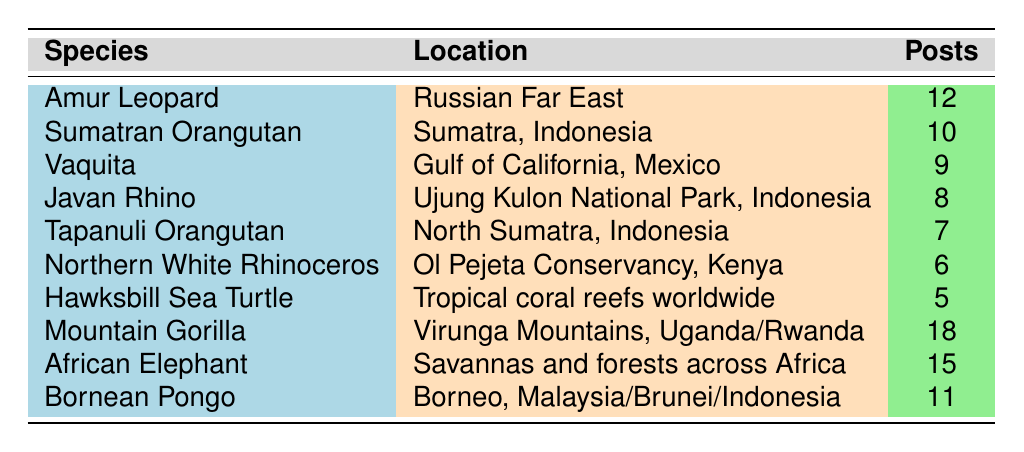What species has the highest number of highlighted posts? The species with the highest number of highlighted posts is the Mountain Gorilla, which has 18 posts.
Answer: Mountain Gorilla How many posts were highlighted for the African Elephant? The African Elephant has 15 highlighted posts as indicated in the table.
Answer: 15 What is the total number of highlighted posts across all species? By summing the highlighted posts: 12 + 10 + 9 + 8 + 7 + 6 + 5 + 18 + 15 + 11 = 91, the total number of highlighted posts across all species is 91.
Answer: 91 Is the Javan Rhino considered critically endangered? According to the table, the Javan Rhino is listed as "Critically Endangered," making this statement true.
Answer: Yes What is the average number of highlighted posts for species at the critically endangered status? The critically endangered species (8 in total) have posts highlighted: 12 + 10 + 9 + 8 + 7 + 6 + 5 + 11 = 68. The average is 68/8 = 8.5.
Answer: 8.5 Which location has the most highlighted posts combined from both the Mountain Gorilla and the African Elephant? The Mountain Gorilla is found in the Virunga Mountains, and the African Elephant is found in savannas and forests across Africa. Combining both gives 18 (Mountain Gorilla) + 15 (African Elephant) = 33 posts.
Answer: 33 How many species are found in tropical rainforests according to the table? The species found in tropical rainforests are Sumatran Orangutan, Javan Rhino, and Tapanuli Orangutan, making a total of 3 species.
Answer: 3 Which species has the least highlighted posts, and what is its conservation status? The species with the least highlighted posts is the Hawksbill Sea Turtle with 5 posts, and its conservation status is "Critically Endangered."
Answer: Hawksbill Sea Turtle, Critically Endangered What is the difference in highlighted posts between the Mountain Gorilla and the Bornean Pongo? The Mountain Gorilla has 18 highlighted posts while the Bornean Pongo has 11. The difference is 18 - 11 = 7 posts.
Answer: 7 Which habitat is shared by the Sumatran and Tapanuli Orangutan? Both species are described as inhabiting tropical rainforest, showing they share this habitat type.
Answer: Tropical rainforest 